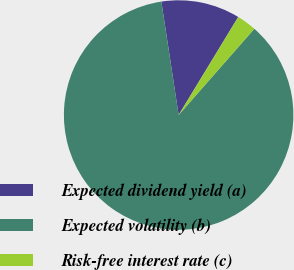Convert chart. <chart><loc_0><loc_0><loc_500><loc_500><pie_chart><fcel>Expected dividend yield (a)<fcel>Expected volatility (b)<fcel>Risk-free interest rate (c)<nl><fcel>11.1%<fcel>86.13%<fcel>2.77%<nl></chart> 